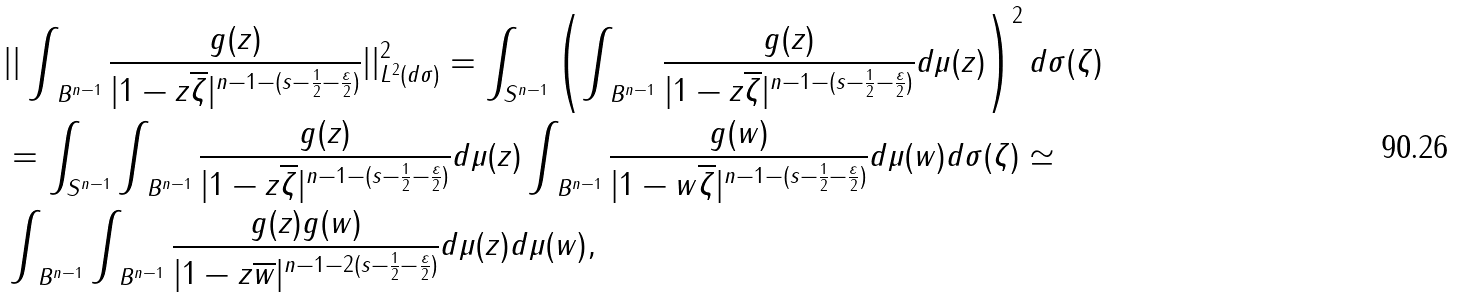Convert formula to latex. <formula><loc_0><loc_0><loc_500><loc_500>& | | \int _ { \ B ^ { n - 1 } } \frac { g ( z ) } { | 1 - z \overline { \zeta } | ^ { n - 1 - ( s - \frac { 1 } { 2 } - \frac { \varepsilon } 2 ) } } | | _ { L ^ { 2 } ( d \sigma ) } ^ { 2 } = \int _ { { S } ^ { n - 1 } } \left ( \int _ { \ B ^ { n - 1 } } \frac { g ( z ) } { | 1 - z \overline { \zeta } | ^ { n - 1 - ( s - \frac { 1 } { 2 } - \frac { \varepsilon } 2 ) } } d \mu ( z ) \right ) ^ { 2 } d \sigma ( \zeta ) \\ & = \int _ { { S } ^ { n - 1 } } \int _ { \ B ^ { n - 1 } } \frac { g ( z ) } { | 1 - z \overline { \zeta } | ^ { n - 1 - ( s - \frac { 1 } { 2 } - \frac { \varepsilon } 2 ) } } d \mu ( z ) \int _ { \ B ^ { n - 1 } } \frac { g ( w ) } { | 1 - w \overline { \zeta } | ^ { n - 1 - ( s - \frac { 1 } { 2 } - \frac { \varepsilon } 2 ) } } d \mu ( w ) d \sigma ( \zeta ) \simeq \\ & \int _ { \ B ^ { n - 1 } } \int _ { \ B ^ { n - 1 } } \frac { g ( z ) g ( w ) } { | 1 - z \overline { w } | ^ { n - 1 - 2 ( s - \frac { 1 } { 2 } - \frac { \varepsilon } 2 ) } } d \mu ( z ) d \mu ( w ) ,</formula> 